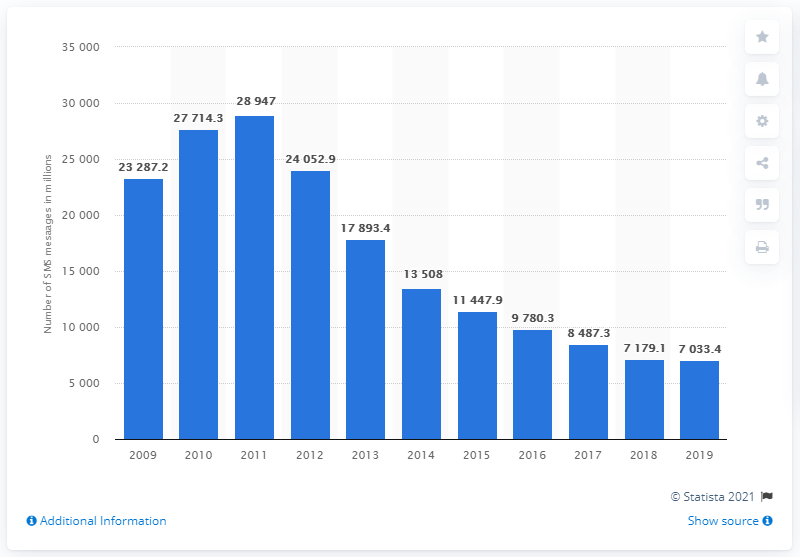Highlight a few significant elements in this photo. In 2011, a total of 28,947 SMS messages were sent and received in Singapore. 